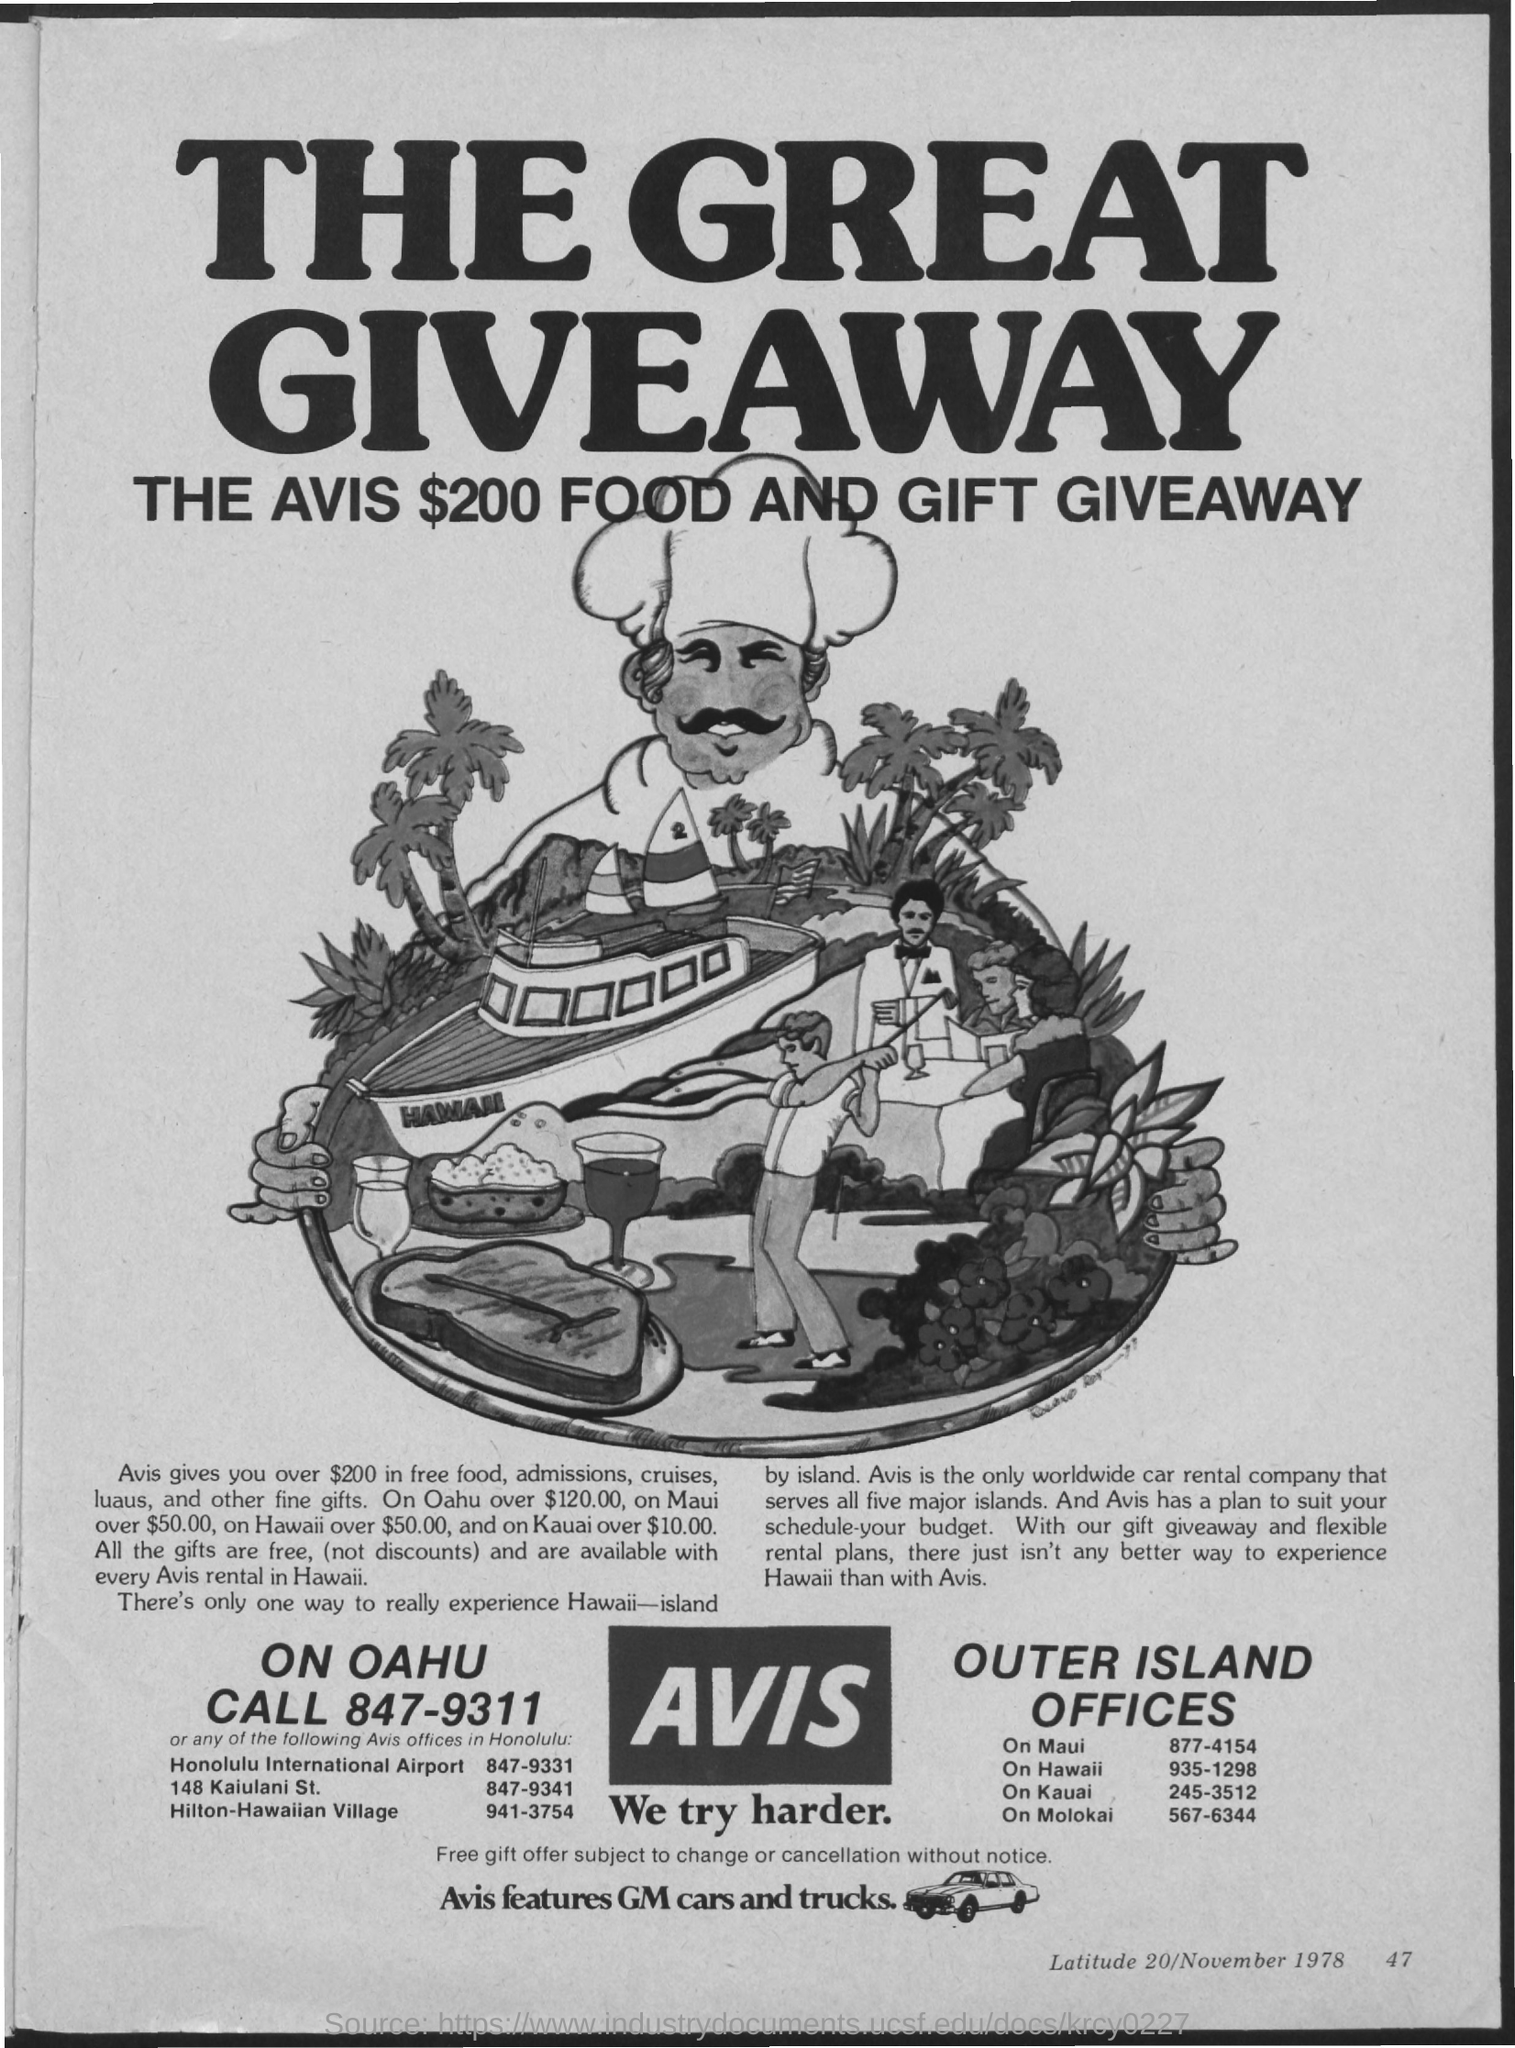Outline some significant characteristics in this image. The title of the document is "What is the Title of the document? The great giveaway.. 